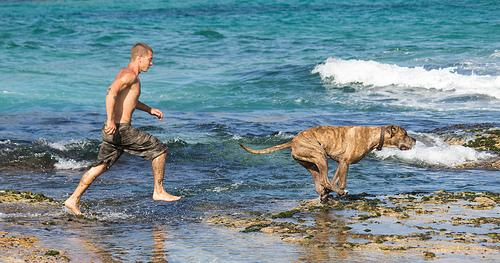Name two specific features about the dog's appearance. The dog is brindle-colored, or brown and black, and has a brown collar. What objects in the image are interacting with the water? The objects interacting with the water are the dog, the man walking in the water, and the black rocks. What's the predominant color of the ocean in the image? The predominant color of the ocean in the image is bluegreen. What can you see near the shoreline in the image? Near the shoreline, there are sand, black colored rocks, breaking ocean waves, and a man running. Can you count how many men are in the image? Also, describe what they are wearing. There are 2 men in the image. One is shirtless and wearing shorts, while the other is wearing grey shorts and green camo swim trunks. Can you comment on the image quality, based on the given information? The image quality seems to be clear and high-resolution, with detailed objects and many elements captured in a large format (Width: 457, Height: 457). Who is chasing whom in the image? One man is chasing the big brown dog, as it runs and plays in the water. How many dogs are in the image? Describe their actions. There is one dog in the image, and it is running and playing in the ocean water near the shoreline. How can the sentiment of the image be described? The image portrays a lively and positive sentiment, with people and dogs enjoying their time at the beach. From the given information, can you infer if it's an action-filled moment in the image? Yes, it's an action-filled moment in the image: a man is chasing his dog, as they play and run in the ocean water near the shore. 